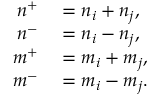<formula> <loc_0><loc_0><loc_500><loc_500>\begin{array} { r l } { n ^ { + } } & = n _ { i } + n _ { j } , } \\ { n ^ { - } } & = n _ { i } - n _ { j } , } \\ { m ^ { + } } & = m _ { i } + m _ { j } , } \\ { m ^ { - } } & = m _ { i } - m _ { j } . } \end{array}</formula> 